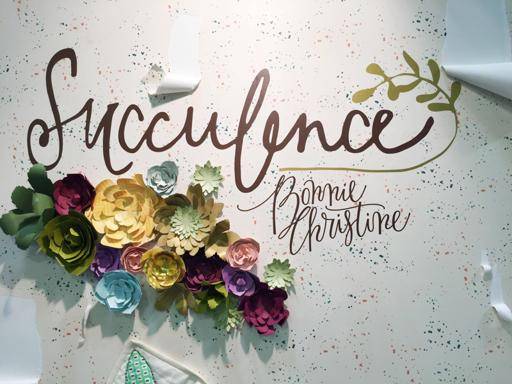What is depicted in the image? The image displays an artistic wall decoration featuring the word 'Succulence' crafted in a elegant cursive script, accompanied by a vibrant array of paper flowers in various colors positioned below the text. This setup could be part of a decor for a special event or a creative display in a retail or personal space. 